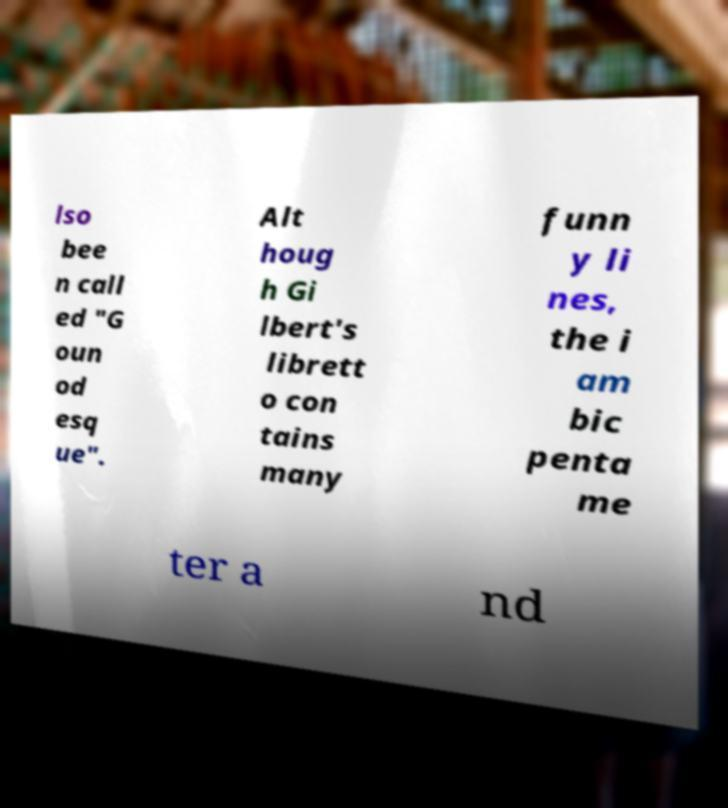Please identify and transcribe the text found in this image. lso bee n call ed "G oun od esq ue". Alt houg h Gi lbert's librett o con tains many funn y li nes, the i am bic penta me ter a nd 